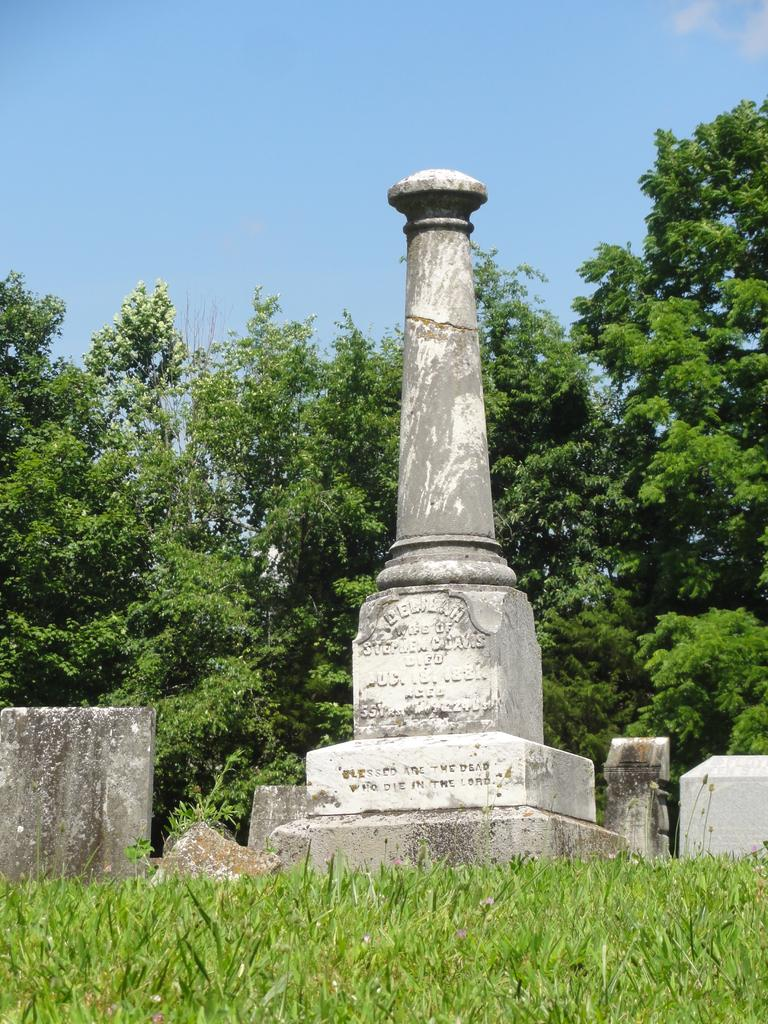What is the main structure in the image? There is a memorial stone pillar in the image. What is the ground covered with? The land is covered with grass. What can be seen in the background of the image? There are trees in the background of the image. How does the balloon attract attention in the image? There is no balloon present in the image, so it cannot attract attention. 